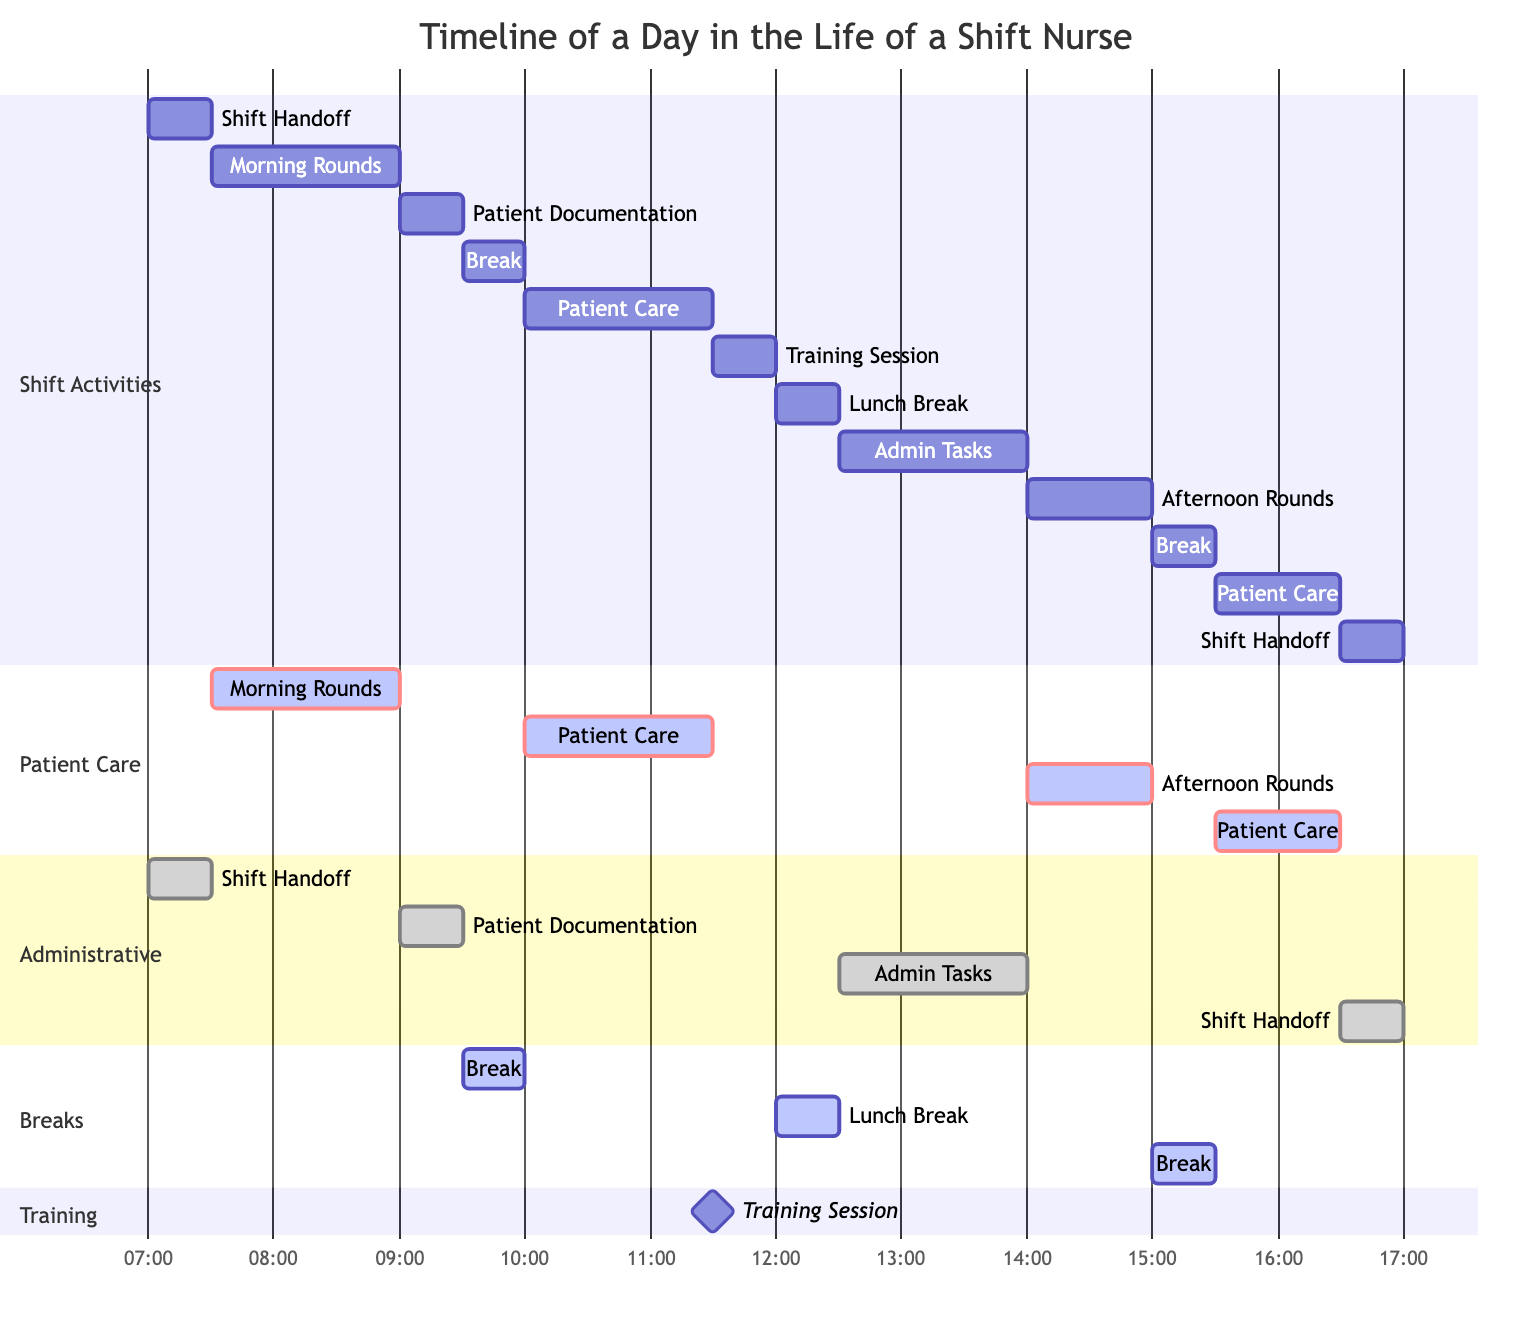What time does the shift handoff take place? The diagram shows a shift handoff occurring at the start of the day at 07:00 and again at the end of the shift at 16:30. Therefore, the first occurrence is at 07:00.
Answer: 07:00 How long is the lunch break? The diagram specifies that the lunch break is scheduled for 30 minutes, starting at 12:00 and ending at 12:30.
Answer: 30 minutes What activity follows the morning rounds? After the morning rounds, which take place from 07:30 to 09:00, the next activity in the timeline is patient documentation.
Answer: Patient Documentation How many breaks are scheduled during the shift? The diagram lists three designated breaks: one at 09:30, one for lunch at 12:00, and another at 15:00. Therefore, there are three breaks scheduled.
Answer: Three What is unique about the training session compared to other activities? The training session is designated as a milestone, which differentiates it from the other activities that are classified as active or done. This indicates a significant focus on training within the shift.
Answer: Milestone What is the duration of patient care activities in total? There are three patient care activities shown in the diagram: one lasting 90 minutes (10:00), one lasting 60 minutes (15:30), and one lasting 60 minutes from the afternoon rounds (14:00). The total duration is 90 + 60 + 60 = 210 minutes.
Answer: 210 minutes What time does the last patient care activity end? The last patient care activity starts at 15:30 and lasts for 60 minutes, which means it ends at 16:30. Since the shift handoff occurs at the same time, this is also when patient care concludes for that shift.
Answer: 16:30 Which section includes the longest task within it? In the diagram, the "Administrative" section includes the admin tasks, which are scheduled for 90 minutes, making it the longest task within this section.
Answer: Admin Tasks How many distinct sections are present in the diagram? The diagram consists of four distinct sections: Shift Activities, Patient Care, Administrative, and Breaks as outlined in the layout of the Gantt chart.
Answer: Four 